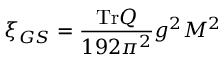<formula> <loc_0><loc_0><loc_500><loc_500>\xi _ { G S } = { \frac { T r Q } { 1 9 2 \pi ^ { 2 } } } g ^ { 2 } M ^ { 2 }</formula> 